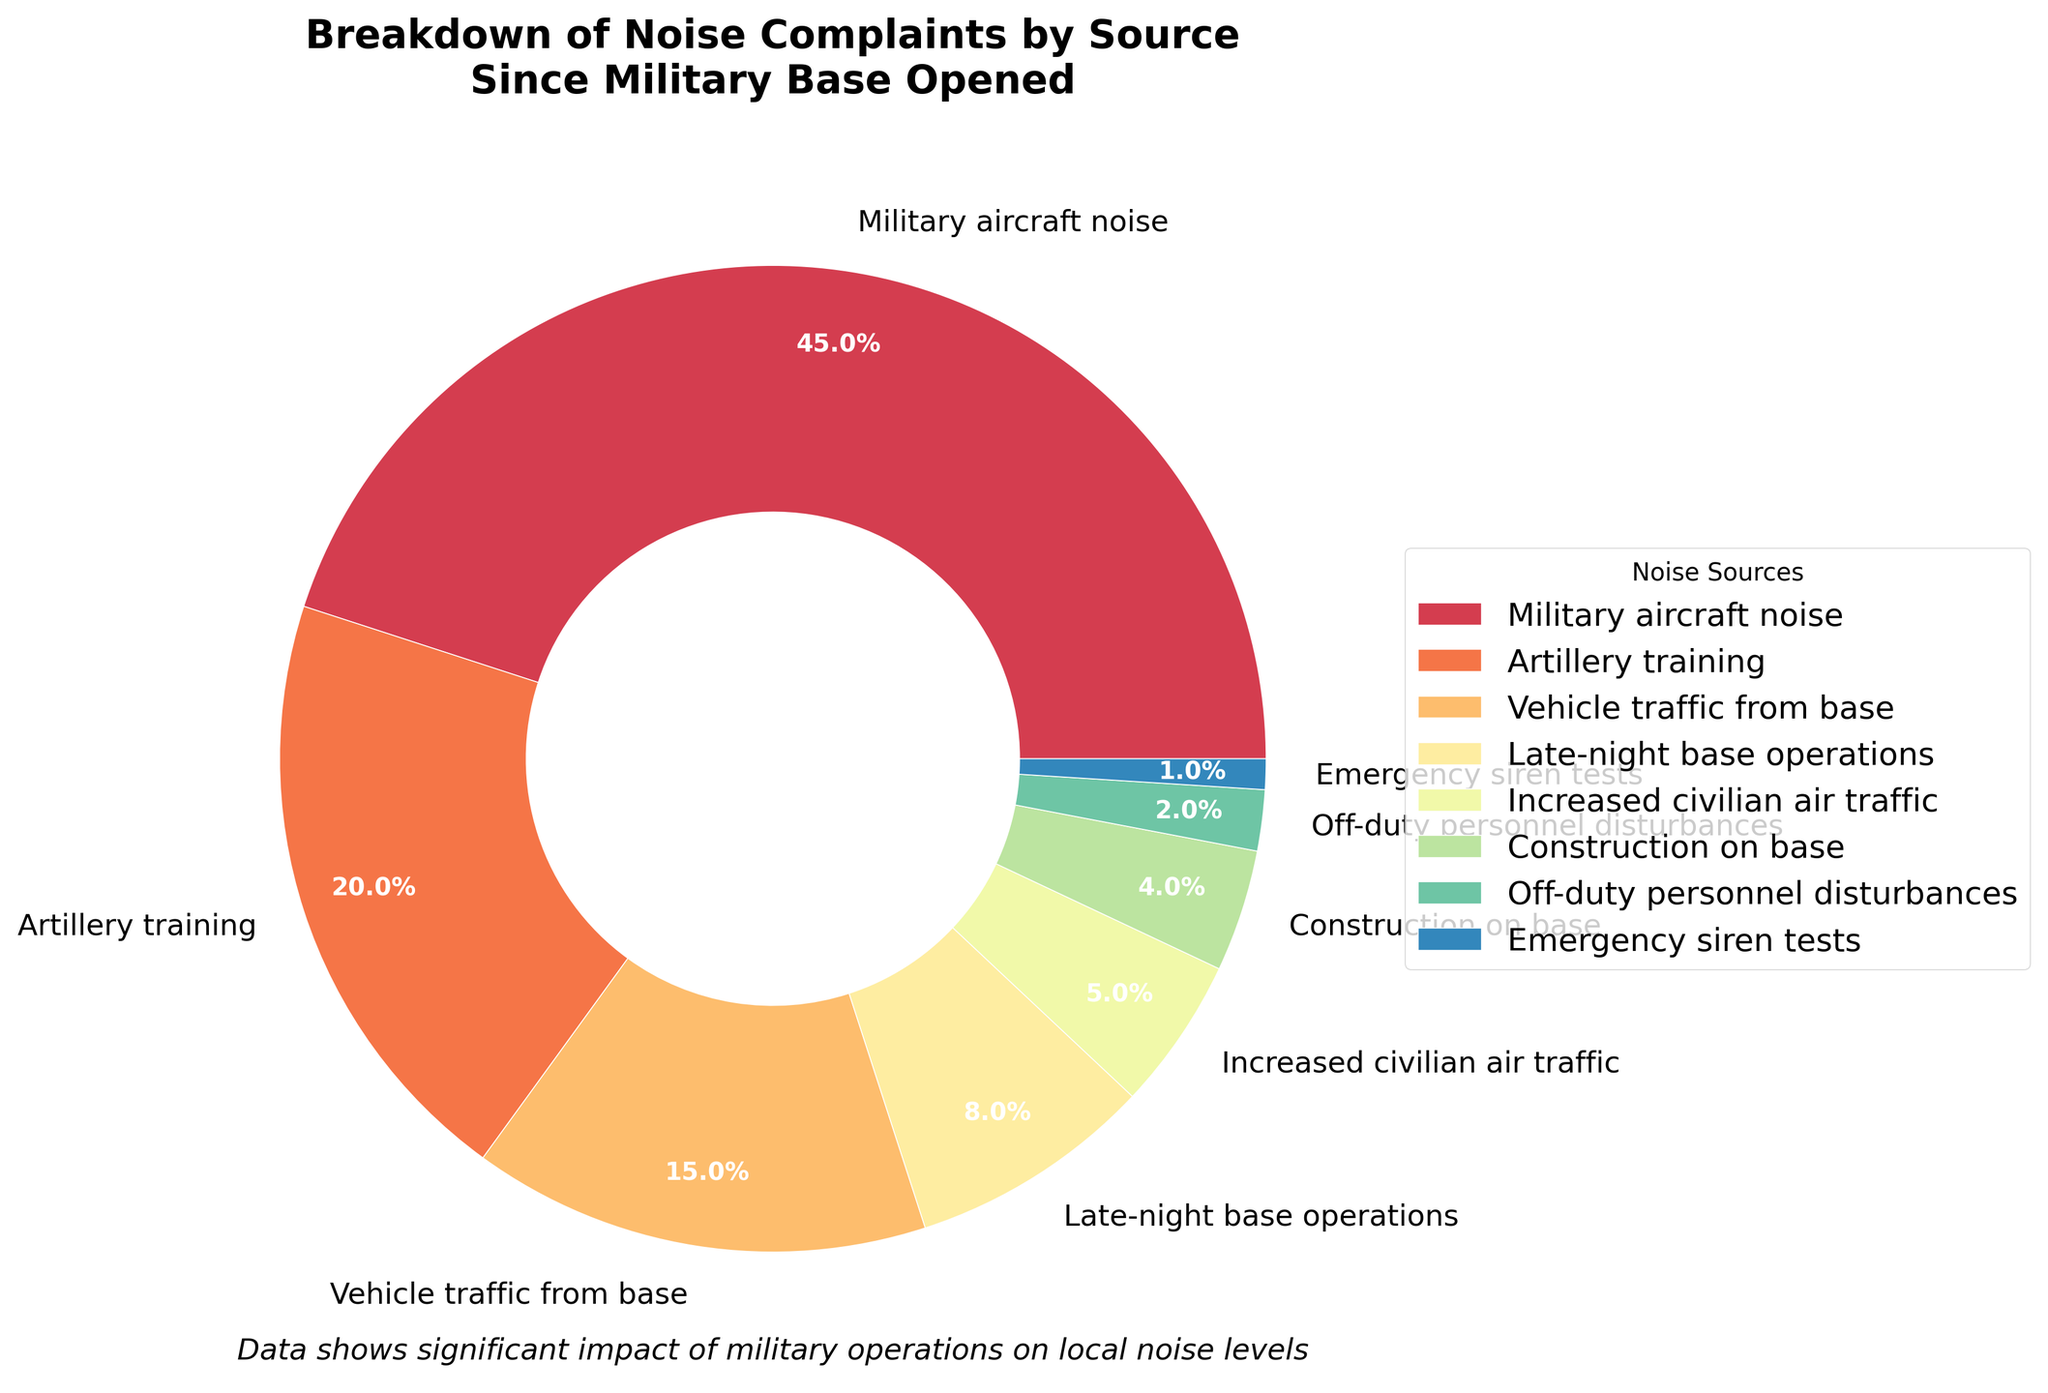Which source is responsible for the highest percentage of noise complaints? By looking at the pie chart, the largest section corresponds to Military aircraft noise, which accounts for 45% of the complaints.
Answer: Military aircraft noise What percentage of noise complaints are caused by artillery training compared to late-night base operations? The chart shows that artillery training is responsible for 20% of the noise complaints, while late-night base operations account for 8%. Therefore, artillery training has a higher percentage.
Answer: Artillery training How much more do military aircraft noise complaints contribute compared to off-duty personnel disturbances? Military aircraft noise is 45% of complaints while off-duty personnel disturbances account for 2%. The difference is 45% - 2% = 43%.
Answer: 43% What is the combined percentage of complaints from vehicle traffic from the base and construction on the base? Vehicle traffic from the base is 15%, and construction on the base is 4%. Adding these together, 15% + 4% = 19%.
Answer: 19% Which sources of noise complaints make up less than 10% each? From the pie chart, sources making up less than 10% each are: Late-night base operations (8%), Increased civilian air traffic (5%), Construction on base (4%), Off-duty personnel disturbances (2%), and Emergency siren tests (1%).
Answer: Late-night base operations, Increased civilian air traffic, Construction on base, Off-duty personnel disturbances, Emergency siren tests How much more do combined military-related sources contribute to noise complaints compared to civilian-related sources? Military-related sources include: Military aircraft noise (45%), Artillery training (20%), Vehicle traffic from base (15%), Late-night base operations (8%), Construction on base (4%), Off-duty personnel disturbances (2%), and Emergency siren tests (1%) which sums up to 95%. Civilian-related sources include only Increased civilian air traffic (5%). The difference is 95% - 5% = 90%.
Answer: 90% Which source category in the pie chart appears the smallest? The smallest section in the pie chart is designated to Emergency siren tests, which account for 1% of the total noise complaints.
Answer: Emergency siren tests 